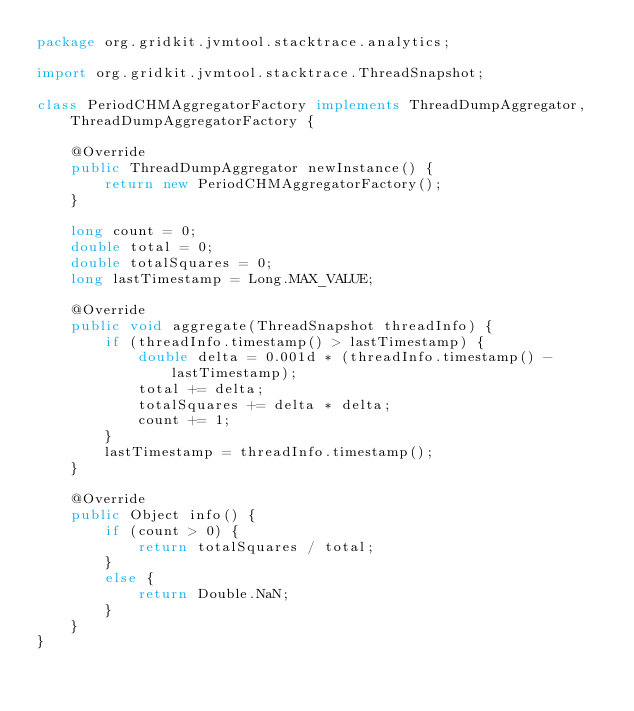<code> <loc_0><loc_0><loc_500><loc_500><_Java_>package org.gridkit.jvmtool.stacktrace.analytics;

import org.gridkit.jvmtool.stacktrace.ThreadSnapshot;

class PeriodCHMAggregatorFactory implements ThreadDumpAggregator, ThreadDumpAggregatorFactory {

    @Override
    public ThreadDumpAggregator newInstance() {
        return new PeriodCHMAggregatorFactory();
    }

    long count = 0;
    double total = 0;
    double totalSquares = 0;
    long lastTimestamp = Long.MAX_VALUE;

    @Override
    public void aggregate(ThreadSnapshot threadInfo) {
        if (threadInfo.timestamp() > lastTimestamp) {
            double delta = 0.001d * (threadInfo.timestamp() - lastTimestamp);
            total += delta;
            totalSquares += delta * delta;
            count += 1;
        }
        lastTimestamp = threadInfo.timestamp();
    }

    @Override
    public Object info() {
        if (count > 0) {
            return totalSquares / total;
        }
        else {
            return Double.NaN;
        }
    }
}
</code> 